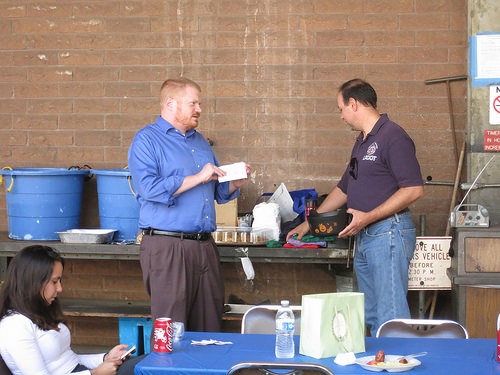<image>
Is there a soda behind the woman? No. The soda is not behind the woman. From this viewpoint, the soda appears to be positioned elsewhere in the scene. 